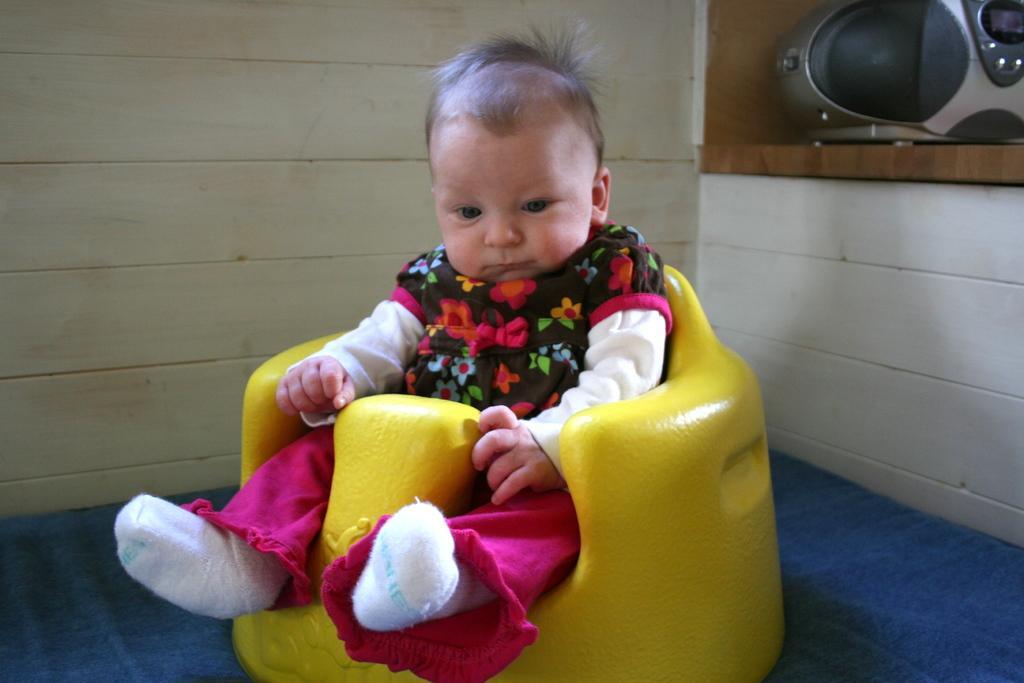Could you give a brief overview of what you see in this image? In this picture we can see a baby is seated on the chair, in the background we can find a wall, and also we can see a carpet. 